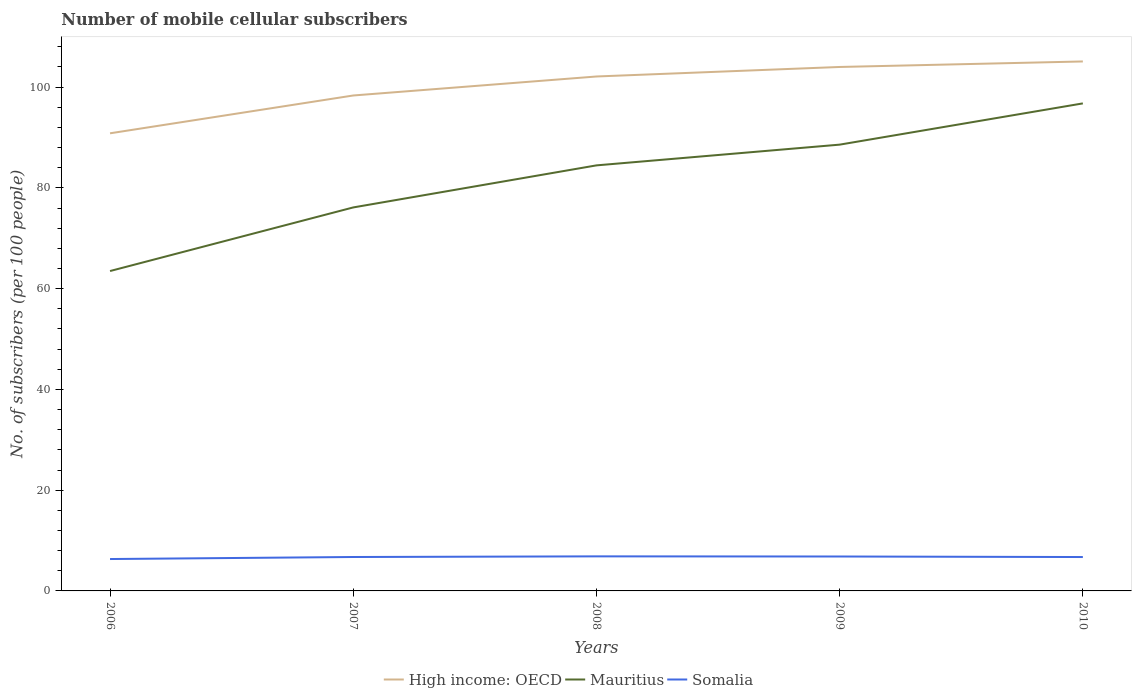Across all years, what is the maximum number of mobile cellular subscribers in Mauritius?
Give a very brief answer. 63.49. What is the total number of mobile cellular subscribers in Mauritius in the graph?
Ensure brevity in your answer.  -8.35. What is the difference between the highest and the second highest number of mobile cellular subscribers in High income: OECD?
Your answer should be compact. 14.26. How many lines are there?
Ensure brevity in your answer.  3. What is the difference between two consecutive major ticks on the Y-axis?
Your response must be concise. 20. Where does the legend appear in the graph?
Keep it short and to the point. Bottom center. How many legend labels are there?
Provide a succinct answer. 3. What is the title of the graph?
Your answer should be very brief. Number of mobile cellular subscribers. What is the label or title of the X-axis?
Offer a very short reply. Years. What is the label or title of the Y-axis?
Offer a very short reply. No. of subscribers (per 100 people). What is the No. of subscribers (per 100 people) in High income: OECD in 2006?
Give a very brief answer. 90.83. What is the No. of subscribers (per 100 people) in Mauritius in 2006?
Provide a short and direct response. 63.49. What is the No. of subscribers (per 100 people) in Somalia in 2006?
Offer a terse response. 6.33. What is the No. of subscribers (per 100 people) of High income: OECD in 2007?
Give a very brief answer. 98.34. What is the No. of subscribers (per 100 people) in Mauritius in 2007?
Ensure brevity in your answer.  76.12. What is the No. of subscribers (per 100 people) of Somalia in 2007?
Your response must be concise. 6.73. What is the No. of subscribers (per 100 people) of High income: OECD in 2008?
Your response must be concise. 102.11. What is the No. of subscribers (per 100 people) in Mauritius in 2008?
Your answer should be very brief. 84.47. What is the No. of subscribers (per 100 people) in Somalia in 2008?
Provide a short and direct response. 6.86. What is the No. of subscribers (per 100 people) of High income: OECD in 2009?
Offer a very short reply. 104. What is the No. of subscribers (per 100 people) in Mauritius in 2009?
Give a very brief answer. 88.58. What is the No. of subscribers (per 100 people) of Somalia in 2009?
Ensure brevity in your answer.  6.83. What is the No. of subscribers (per 100 people) of High income: OECD in 2010?
Offer a very short reply. 105.09. What is the No. of subscribers (per 100 people) of Mauritius in 2010?
Provide a succinct answer. 96.77. What is the No. of subscribers (per 100 people) in Somalia in 2010?
Offer a terse response. 6.73. Across all years, what is the maximum No. of subscribers (per 100 people) in High income: OECD?
Ensure brevity in your answer.  105.09. Across all years, what is the maximum No. of subscribers (per 100 people) in Mauritius?
Make the answer very short. 96.77. Across all years, what is the maximum No. of subscribers (per 100 people) of Somalia?
Provide a short and direct response. 6.86. Across all years, what is the minimum No. of subscribers (per 100 people) in High income: OECD?
Give a very brief answer. 90.83. Across all years, what is the minimum No. of subscribers (per 100 people) of Mauritius?
Offer a very short reply. 63.49. Across all years, what is the minimum No. of subscribers (per 100 people) in Somalia?
Give a very brief answer. 6.33. What is the total No. of subscribers (per 100 people) in High income: OECD in the graph?
Provide a succinct answer. 500.37. What is the total No. of subscribers (per 100 people) of Mauritius in the graph?
Make the answer very short. 409.43. What is the total No. of subscribers (per 100 people) in Somalia in the graph?
Provide a short and direct response. 33.48. What is the difference between the No. of subscribers (per 100 people) of High income: OECD in 2006 and that in 2007?
Your response must be concise. -7.51. What is the difference between the No. of subscribers (per 100 people) of Mauritius in 2006 and that in 2007?
Provide a short and direct response. -12.63. What is the difference between the No. of subscribers (per 100 people) of Somalia in 2006 and that in 2007?
Make the answer very short. -0.4. What is the difference between the No. of subscribers (per 100 people) of High income: OECD in 2006 and that in 2008?
Your response must be concise. -11.28. What is the difference between the No. of subscribers (per 100 people) of Mauritius in 2006 and that in 2008?
Provide a short and direct response. -20.97. What is the difference between the No. of subscribers (per 100 people) in Somalia in 2006 and that in 2008?
Offer a terse response. -0.53. What is the difference between the No. of subscribers (per 100 people) in High income: OECD in 2006 and that in 2009?
Ensure brevity in your answer.  -13.17. What is the difference between the No. of subscribers (per 100 people) of Mauritius in 2006 and that in 2009?
Your answer should be very brief. -25.09. What is the difference between the No. of subscribers (per 100 people) in Somalia in 2006 and that in 2009?
Your answer should be compact. -0.5. What is the difference between the No. of subscribers (per 100 people) of High income: OECD in 2006 and that in 2010?
Offer a terse response. -14.26. What is the difference between the No. of subscribers (per 100 people) of Mauritius in 2006 and that in 2010?
Offer a very short reply. -33.28. What is the difference between the No. of subscribers (per 100 people) in Somalia in 2006 and that in 2010?
Your answer should be very brief. -0.4. What is the difference between the No. of subscribers (per 100 people) of High income: OECD in 2007 and that in 2008?
Give a very brief answer. -3.77. What is the difference between the No. of subscribers (per 100 people) of Mauritius in 2007 and that in 2008?
Make the answer very short. -8.35. What is the difference between the No. of subscribers (per 100 people) of Somalia in 2007 and that in 2008?
Provide a succinct answer. -0.13. What is the difference between the No. of subscribers (per 100 people) of High income: OECD in 2007 and that in 2009?
Ensure brevity in your answer.  -5.66. What is the difference between the No. of subscribers (per 100 people) in Mauritius in 2007 and that in 2009?
Ensure brevity in your answer.  -12.46. What is the difference between the No. of subscribers (per 100 people) of Somalia in 2007 and that in 2009?
Keep it short and to the point. -0.1. What is the difference between the No. of subscribers (per 100 people) in High income: OECD in 2007 and that in 2010?
Your response must be concise. -6.75. What is the difference between the No. of subscribers (per 100 people) in Mauritius in 2007 and that in 2010?
Your response must be concise. -20.65. What is the difference between the No. of subscribers (per 100 people) of Somalia in 2007 and that in 2010?
Your answer should be very brief. 0.01. What is the difference between the No. of subscribers (per 100 people) in High income: OECD in 2008 and that in 2009?
Your answer should be compact. -1.89. What is the difference between the No. of subscribers (per 100 people) in Mauritius in 2008 and that in 2009?
Your response must be concise. -4.12. What is the difference between the No. of subscribers (per 100 people) of Somalia in 2008 and that in 2009?
Provide a short and direct response. 0.03. What is the difference between the No. of subscribers (per 100 people) in High income: OECD in 2008 and that in 2010?
Your answer should be compact. -2.98. What is the difference between the No. of subscribers (per 100 people) of Mauritius in 2008 and that in 2010?
Your answer should be compact. -12.3. What is the difference between the No. of subscribers (per 100 people) in Somalia in 2008 and that in 2010?
Offer a terse response. 0.13. What is the difference between the No. of subscribers (per 100 people) of High income: OECD in 2009 and that in 2010?
Your answer should be very brief. -1.1. What is the difference between the No. of subscribers (per 100 people) in Mauritius in 2009 and that in 2010?
Offer a very short reply. -8.19. What is the difference between the No. of subscribers (per 100 people) of Somalia in 2009 and that in 2010?
Keep it short and to the point. 0.11. What is the difference between the No. of subscribers (per 100 people) in High income: OECD in 2006 and the No. of subscribers (per 100 people) in Mauritius in 2007?
Offer a very short reply. 14.71. What is the difference between the No. of subscribers (per 100 people) in High income: OECD in 2006 and the No. of subscribers (per 100 people) in Somalia in 2007?
Your answer should be compact. 84.1. What is the difference between the No. of subscribers (per 100 people) of Mauritius in 2006 and the No. of subscribers (per 100 people) of Somalia in 2007?
Offer a very short reply. 56.76. What is the difference between the No. of subscribers (per 100 people) of High income: OECD in 2006 and the No. of subscribers (per 100 people) of Mauritius in 2008?
Ensure brevity in your answer.  6.37. What is the difference between the No. of subscribers (per 100 people) of High income: OECD in 2006 and the No. of subscribers (per 100 people) of Somalia in 2008?
Provide a succinct answer. 83.97. What is the difference between the No. of subscribers (per 100 people) of Mauritius in 2006 and the No. of subscribers (per 100 people) of Somalia in 2008?
Make the answer very short. 56.63. What is the difference between the No. of subscribers (per 100 people) of High income: OECD in 2006 and the No. of subscribers (per 100 people) of Mauritius in 2009?
Your answer should be compact. 2.25. What is the difference between the No. of subscribers (per 100 people) of High income: OECD in 2006 and the No. of subscribers (per 100 people) of Somalia in 2009?
Make the answer very short. 84. What is the difference between the No. of subscribers (per 100 people) in Mauritius in 2006 and the No. of subscribers (per 100 people) in Somalia in 2009?
Provide a succinct answer. 56.66. What is the difference between the No. of subscribers (per 100 people) of High income: OECD in 2006 and the No. of subscribers (per 100 people) of Mauritius in 2010?
Offer a terse response. -5.94. What is the difference between the No. of subscribers (per 100 people) of High income: OECD in 2006 and the No. of subscribers (per 100 people) of Somalia in 2010?
Ensure brevity in your answer.  84.1. What is the difference between the No. of subscribers (per 100 people) of Mauritius in 2006 and the No. of subscribers (per 100 people) of Somalia in 2010?
Offer a terse response. 56.77. What is the difference between the No. of subscribers (per 100 people) of High income: OECD in 2007 and the No. of subscribers (per 100 people) of Mauritius in 2008?
Make the answer very short. 13.87. What is the difference between the No. of subscribers (per 100 people) of High income: OECD in 2007 and the No. of subscribers (per 100 people) of Somalia in 2008?
Offer a very short reply. 91.48. What is the difference between the No. of subscribers (per 100 people) in Mauritius in 2007 and the No. of subscribers (per 100 people) in Somalia in 2008?
Your answer should be very brief. 69.26. What is the difference between the No. of subscribers (per 100 people) in High income: OECD in 2007 and the No. of subscribers (per 100 people) in Mauritius in 2009?
Provide a short and direct response. 9.76. What is the difference between the No. of subscribers (per 100 people) in High income: OECD in 2007 and the No. of subscribers (per 100 people) in Somalia in 2009?
Your response must be concise. 91.51. What is the difference between the No. of subscribers (per 100 people) in Mauritius in 2007 and the No. of subscribers (per 100 people) in Somalia in 2009?
Offer a terse response. 69.28. What is the difference between the No. of subscribers (per 100 people) in High income: OECD in 2007 and the No. of subscribers (per 100 people) in Mauritius in 2010?
Provide a succinct answer. 1.57. What is the difference between the No. of subscribers (per 100 people) in High income: OECD in 2007 and the No. of subscribers (per 100 people) in Somalia in 2010?
Your answer should be compact. 91.61. What is the difference between the No. of subscribers (per 100 people) in Mauritius in 2007 and the No. of subscribers (per 100 people) in Somalia in 2010?
Provide a succinct answer. 69.39. What is the difference between the No. of subscribers (per 100 people) of High income: OECD in 2008 and the No. of subscribers (per 100 people) of Mauritius in 2009?
Your answer should be very brief. 13.53. What is the difference between the No. of subscribers (per 100 people) of High income: OECD in 2008 and the No. of subscribers (per 100 people) of Somalia in 2009?
Your answer should be very brief. 95.27. What is the difference between the No. of subscribers (per 100 people) in Mauritius in 2008 and the No. of subscribers (per 100 people) in Somalia in 2009?
Provide a succinct answer. 77.63. What is the difference between the No. of subscribers (per 100 people) in High income: OECD in 2008 and the No. of subscribers (per 100 people) in Mauritius in 2010?
Ensure brevity in your answer.  5.34. What is the difference between the No. of subscribers (per 100 people) of High income: OECD in 2008 and the No. of subscribers (per 100 people) of Somalia in 2010?
Provide a short and direct response. 95.38. What is the difference between the No. of subscribers (per 100 people) in Mauritius in 2008 and the No. of subscribers (per 100 people) in Somalia in 2010?
Keep it short and to the point. 77.74. What is the difference between the No. of subscribers (per 100 people) of High income: OECD in 2009 and the No. of subscribers (per 100 people) of Mauritius in 2010?
Offer a very short reply. 7.23. What is the difference between the No. of subscribers (per 100 people) in High income: OECD in 2009 and the No. of subscribers (per 100 people) in Somalia in 2010?
Make the answer very short. 97.27. What is the difference between the No. of subscribers (per 100 people) of Mauritius in 2009 and the No. of subscribers (per 100 people) of Somalia in 2010?
Keep it short and to the point. 81.85. What is the average No. of subscribers (per 100 people) of High income: OECD per year?
Offer a terse response. 100.07. What is the average No. of subscribers (per 100 people) in Mauritius per year?
Your answer should be very brief. 81.89. What is the average No. of subscribers (per 100 people) in Somalia per year?
Make the answer very short. 6.7. In the year 2006, what is the difference between the No. of subscribers (per 100 people) in High income: OECD and No. of subscribers (per 100 people) in Mauritius?
Make the answer very short. 27.34. In the year 2006, what is the difference between the No. of subscribers (per 100 people) of High income: OECD and No. of subscribers (per 100 people) of Somalia?
Keep it short and to the point. 84.5. In the year 2006, what is the difference between the No. of subscribers (per 100 people) of Mauritius and No. of subscribers (per 100 people) of Somalia?
Offer a very short reply. 57.16. In the year 2007, what is the difference between the No. of subscribers (per 100 people) of High income: OECD and No. of subscribers (per 100 people) of Mauritius?
Make the answer very short. 22.22. In the year 2007, what is the difference between the No. of subscribers (per 100 people) of High income: OECD and No. of subscribers (per 100 people) of Somalia?
Your answer should be compact. 91.6. In the year 2007, what is the difference between the No. of subscribers (per 100 people) in Mauritius and No. of subscribers (per 100 people) in Somalia?
Your response must be concise. 69.38. In the year 2008, what is the difference between the No. of subscribers (per 100 people) of High income: OECD and No. of subscribers (per 100 people) of Mauritius?
Provide a short and direct response. 17.64. In the year 2008, what is the difference between the No. of subscribers (per 100 people) in High income: OECD and No. of subscribers (per 100 people) in Somalia?
Provide a short and direct response. 95.25. In the year 2008, what is the difference between the No. of subscribers (per 100 people) in Mauritius and No. of subscribers (per 100 people) in Somalia?
Give a very brief answer. 77.61. In the year 2009, what is the difference between the No. of subscribers (per 100 people) in High income: OECD and No. of subscribers (per 100 people) in Mauritius?
Your answer should be very brief. 15.42. In the year 2009, what is the difference between the No. of subscribers (per 100 people) in High income: OECD and No. of subscribers (per 100 people) in Somalia?
Keep it short and to the point. 97.16. In the year 2009, what is the difference between the No. of subscribers (per 100 people) in Mauritius and No. of subscribers (per 100 people) in Somalia?
Offer a very short reply. 81.75. In the year 2010, what is the difference between the No. of subscribers (per 100 people) of High income: OECD and No. of subscribers (per 100 people) of Mauritius?
Make the answer very short. 8.32. In the year 2010, what is the difference between the No. of subscribers (per 100 people) of High income: OECD and No. of subscribers (per 100 people) of Somalia?
Offer a terse response. 98.37. In the year 2010, what is the difference between the No. of subscribers (per 100 people) of Mauritius and No. of subscribers (per 100 people) of Somalia?
Keep it short and to the point. 90.04. What is the ratio of the No. of subscribers (per 100 people) of High income: OECD in 2006 to that in 2007?
Keep it short and to the point. 0.92. What is the ratio of the No. of subscribers (per 100 people) in Mauritius in 2006 to that in 2007?
Offer a terse response. 0.83. What is the ratio of the No. of subscribers (per 100 people) of Somalia in 2006 to that in 2007?
Offer a very short reply. 0.94. What is the ratio of the No. of subscribers (per 100 people) of High income: OECD in 2006 to that in 2008?
Your answer should be compact. 0.89. What is the ratio of the No. of subscribers (per 100 people) in Mauritius in 2006 to that in 2008?
Your answer should be very brief. 0.75. What is the ratio of the No. of subscribers (per 100 people) in Somalia in 2006 to that in 2008?
Your response must be concise. 0.92. What is the ratio of the No. of subscribers (per 100 people) of High income: OECD in 2006 to that in 2009?
Make the answer very short. 0.87. What is the ratio of the No. of subscribers (per 100 people) in Mauritius in 2006 to that in 2009?
Provide a succinct answer. 0.72. What is the ratio of the No. of subscribers (per 100 people) in Somalia in 2006 to that in 2009?
Make the answer very short. 0.93. What is the ratio of the No. of subscribers (per 100 people) of High income: OECD in 2006 to that in 2010?
Your response must be concise. 0.86. What is the ratio of the No. of subscribers (per 100 people) in Mauritius in 2006 to that in 2010?
Provide a succinct answer. 0.66. What is the ratio of the No. of subscribers (per 100 people) of Somalia in 2006 to that in 2010?
Your response must be concise. 0.94. What is the ratio of the No. of subscribers (per 100 people) of High income: OECD in 2007 to that in 2008?
Keep it short and to the point. 0.96. What is the ratio of the No. of subscribers (per 100 people) in Mauritius in 2007 to that in 2008?
Give a very brief answer. 0.9. What is the ratio of the No. of subscribers (per 100 people) of Somalia in 2007 to that in 2008?
Provide a succinct answer. 0.98. What is the ratio of the No. of subscribers (per 100 people) in High income: OECD in 2007 to that in 2009?
Your response must be concise. 0.95. What is the ratio of the No. of subscribers (per 100 people) of Mauritius in 2007 to that in 2009?
Offer a terse response. 0.86. What is the ratio of the No. of subscribers (per 100 people) in Somalia in 2007 to that in 2009?
Your answer should be very brief. 0.99. What is the ratio of the No. of subscribers (per 100 people) of High income: OECD in 2007 to that in 2010?
Your response must be concise. 0.94. What is the ratio of the No. of subscribers (per 100 people) of Mauritius in 2007 to that in 2010?
Offer a terse response. 0.79. What is the ratio of the No. of subscribers (per 100 people) of High income: OECD in 2008 to that in 2009?
Offer a very short reply. 0.98. What is the ratio of the No. of subscribers (per 100 people) of Mauritius in 2008 to that in 2009?
Provide a short and direct response. 0.95. What is the ratio of the No. of subscribers (per 100 people) of High income: OECD in 2008 to that in 2010?
Your answer should be compact. 0.97. What is the ratio of the No. of subscribers (per 100 people) of Mauritius in 2008 to that in 2010?
Offer a terse response. 0.87. What is the ratio of the No. of subscribers (per 100 people) of Somalia in 2008 to that in 2010?
Provide a succinct answer. 1.02. What is the ratio of the No. of subscribers (per 100 people) of High income: OECD in 2009 to that in 2010?
Provide a short and direct response. 0.99. What is the ratio of the No. of subscribers (per 100 people) in Mauritius in 2009 to that in 2010?
Offer a very short reply. 0.92. What is the ratio of the No. of subscribers (per 100 people) of Somalia in 2009 to that in 2010?
Give a very brief answer. 1.02. What is the difference between the highest and the second highest No. of subscribers (per 100 people) in High income: OECD?
Give a very brief answer. 1.1. What is the difference between the highest and the second highest No. of subscribers (per 100 people) of Mauritius?
Give a very brief answer. 8.19. What is the difference between the highest and the second highest No. of subscribers (per 100 people) in Somalia?
Offer a terse response. 0.03. What is the difference between the highest and the lowest No. of subscribers (per 100 people) in High income: OECD?
Provide a succinct answer. 14.26. What is the difference between the highest and the lowest No. of subscribers (per 100 people) of Mauritius?
Offer a terse response. 33.28. What is the difference between the highest and the lowest No. of subscribers (per 100 people) of Somalia?
Provide a succinct answer. 0.53. 